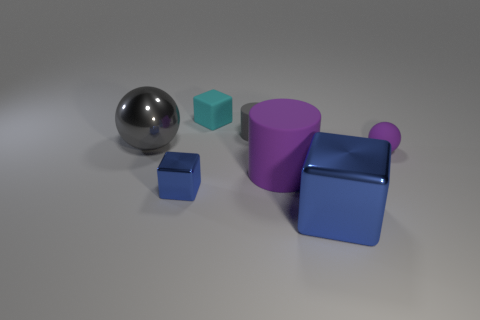Can you describe the colors and shapes of the objects shown? Certainly! The image features a collection of geometric shapes in various colors. There's a shiny silver sphere, a small teal cube, a medium-sized purple cylinder, a large blue cube, and a large blue square with a protruding cylindrical handle. 